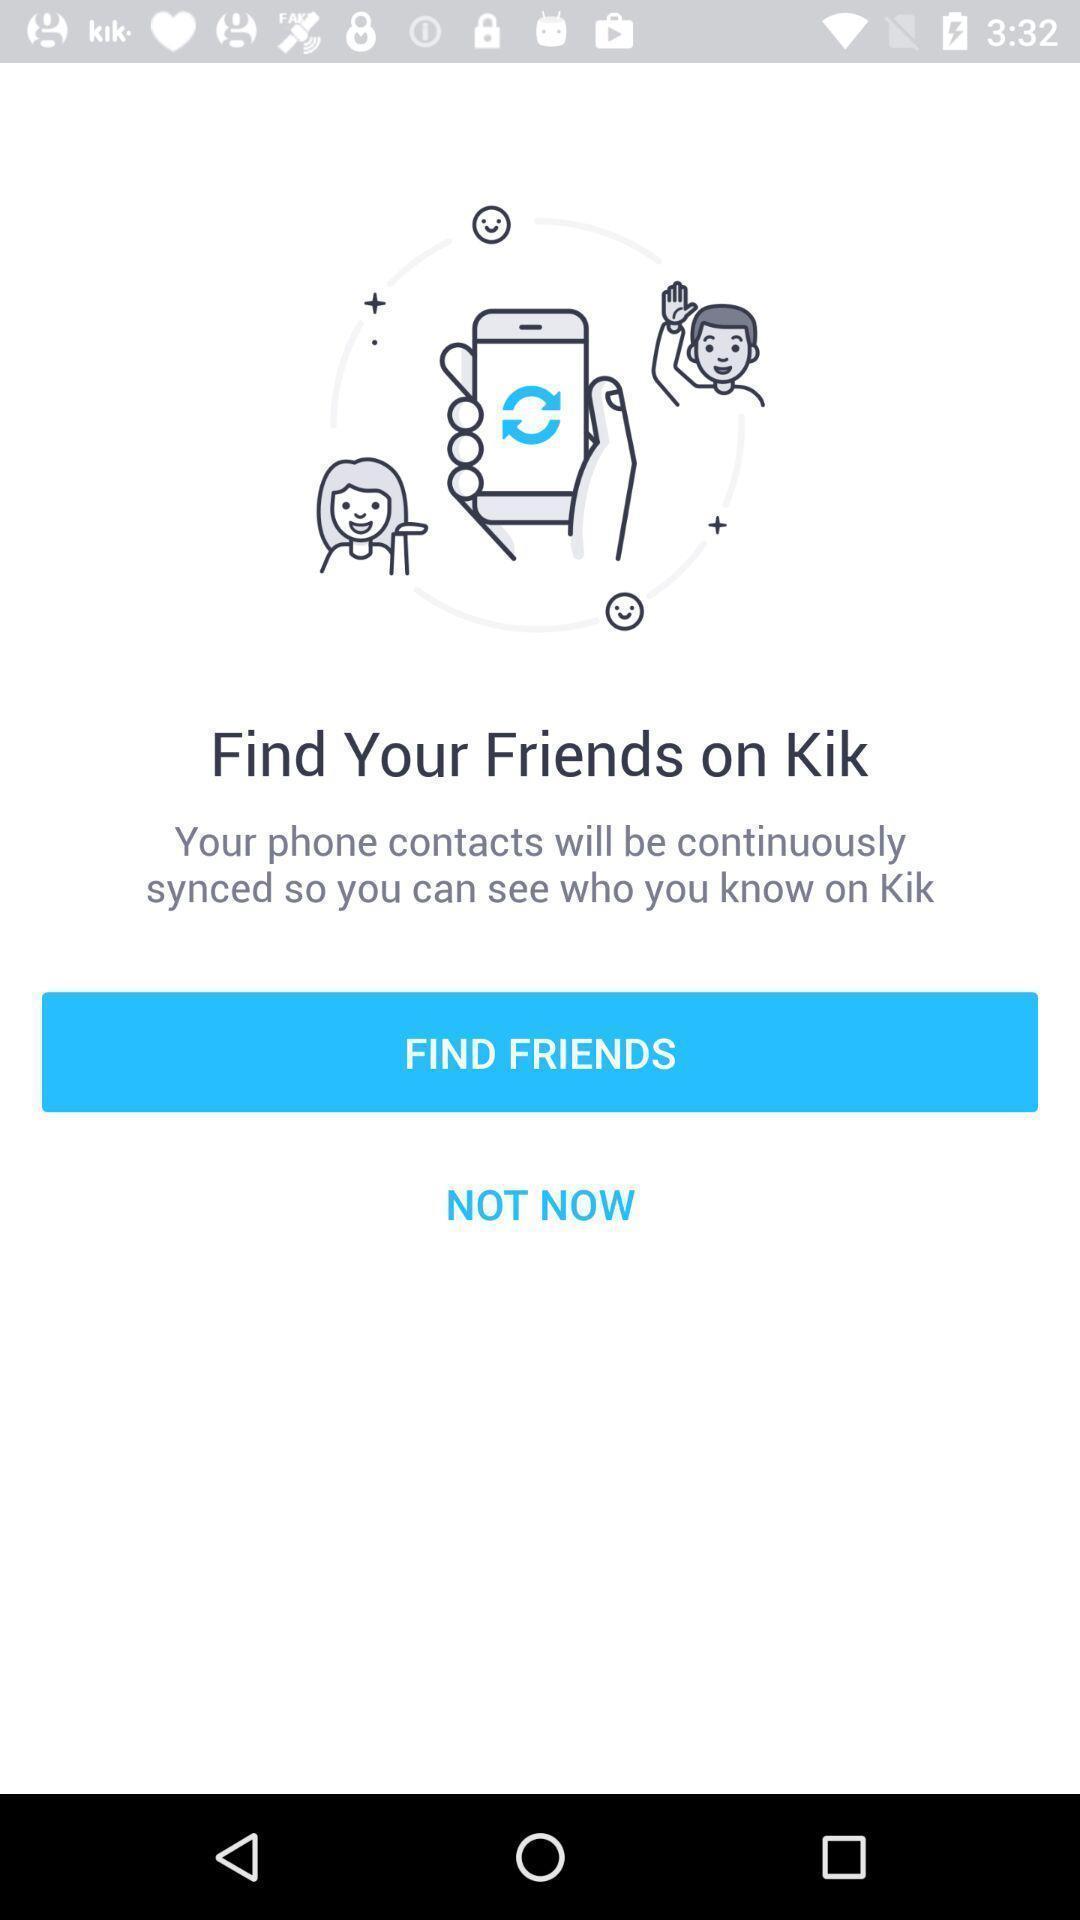Explain the elements present in this screenshot. Page for finding friends of a social app. 